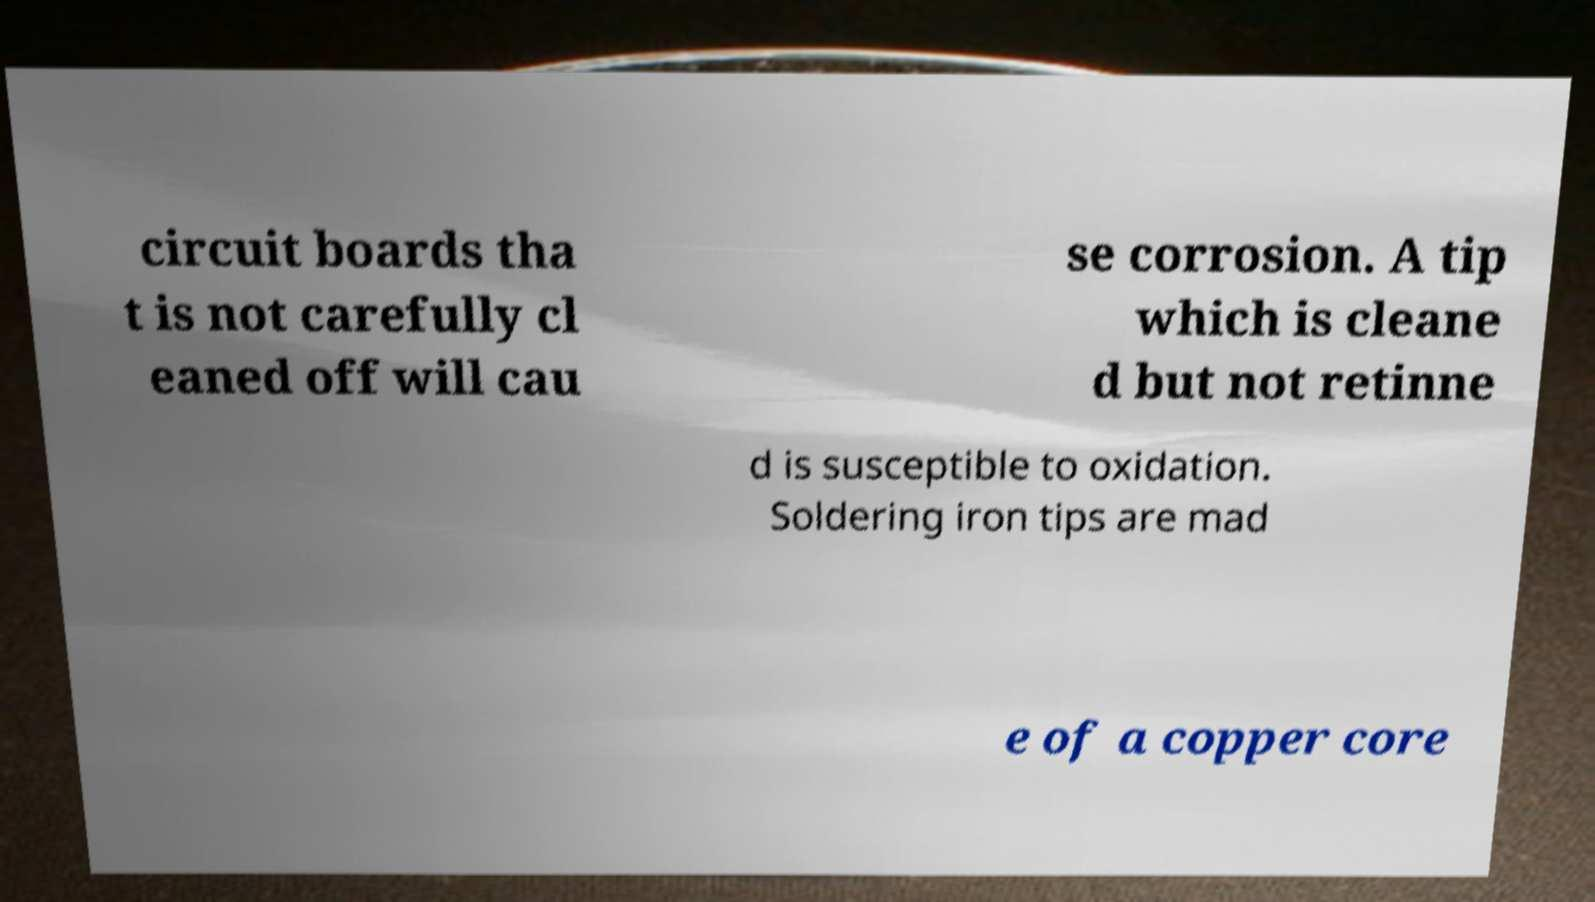Could you extract and type out the text from this image? circuit boards tha t is not carefully cl eaned off will cau se corrosion. A tip which is cleane d but not retinne d is susceptible to oxidation. Soldering iron tips are mad e of a copper core 